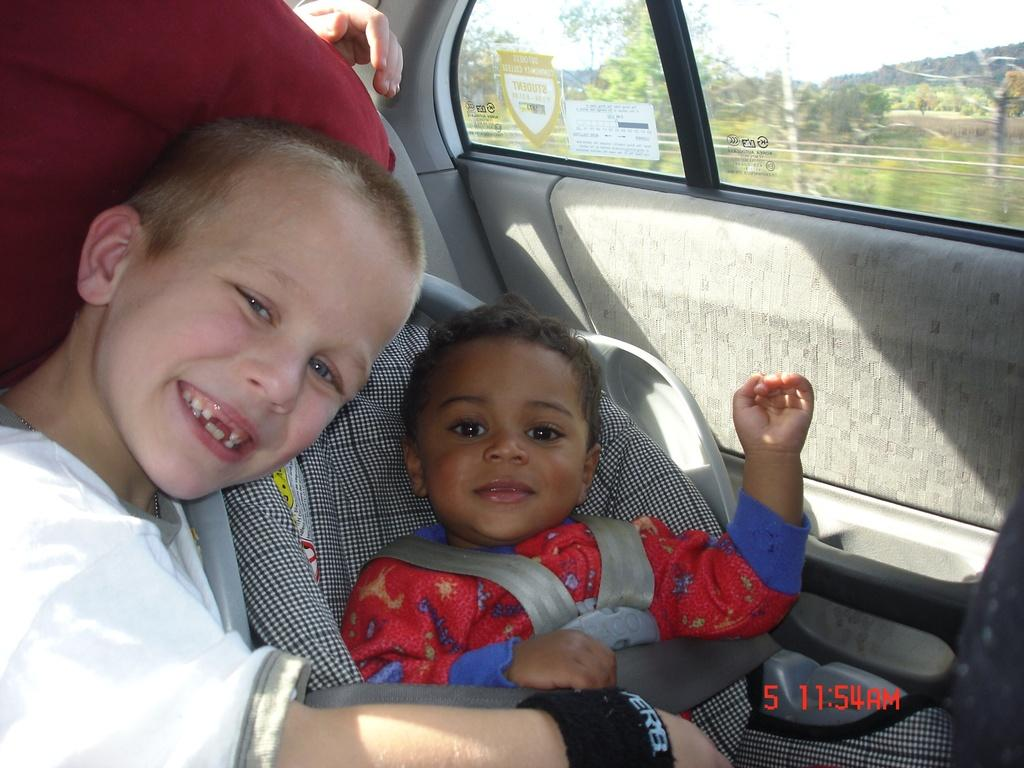Where was the image taken? The image was taken inside a car. How many kids are in the car? There are two kids in the car. What are the kids sitting on? The kids are sitting on a chair. What can be seen outside the car? Trees and plants are visible from the car door. What type of hook is hanging from the car's ceiling in the image? There is no hook hanging from the car's ceiling in the image. How many bikes are parked next to the car in the image? There are no bikes visible in the image; it only shows the interior of the car. 